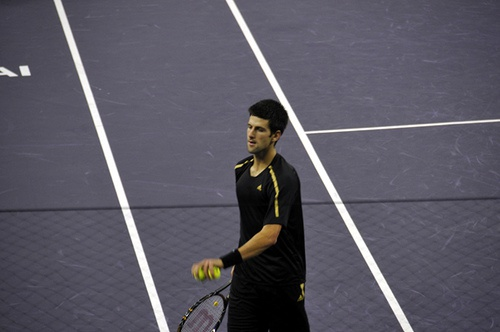Describe the objects in this image and their specific colors. I can see people in black, olive, gray, and tan tones, tennis racket in black and gray tones, sports ball in black, olive, and gray tones, and sports ball in black, olive, gray, and tan tones in this image. 